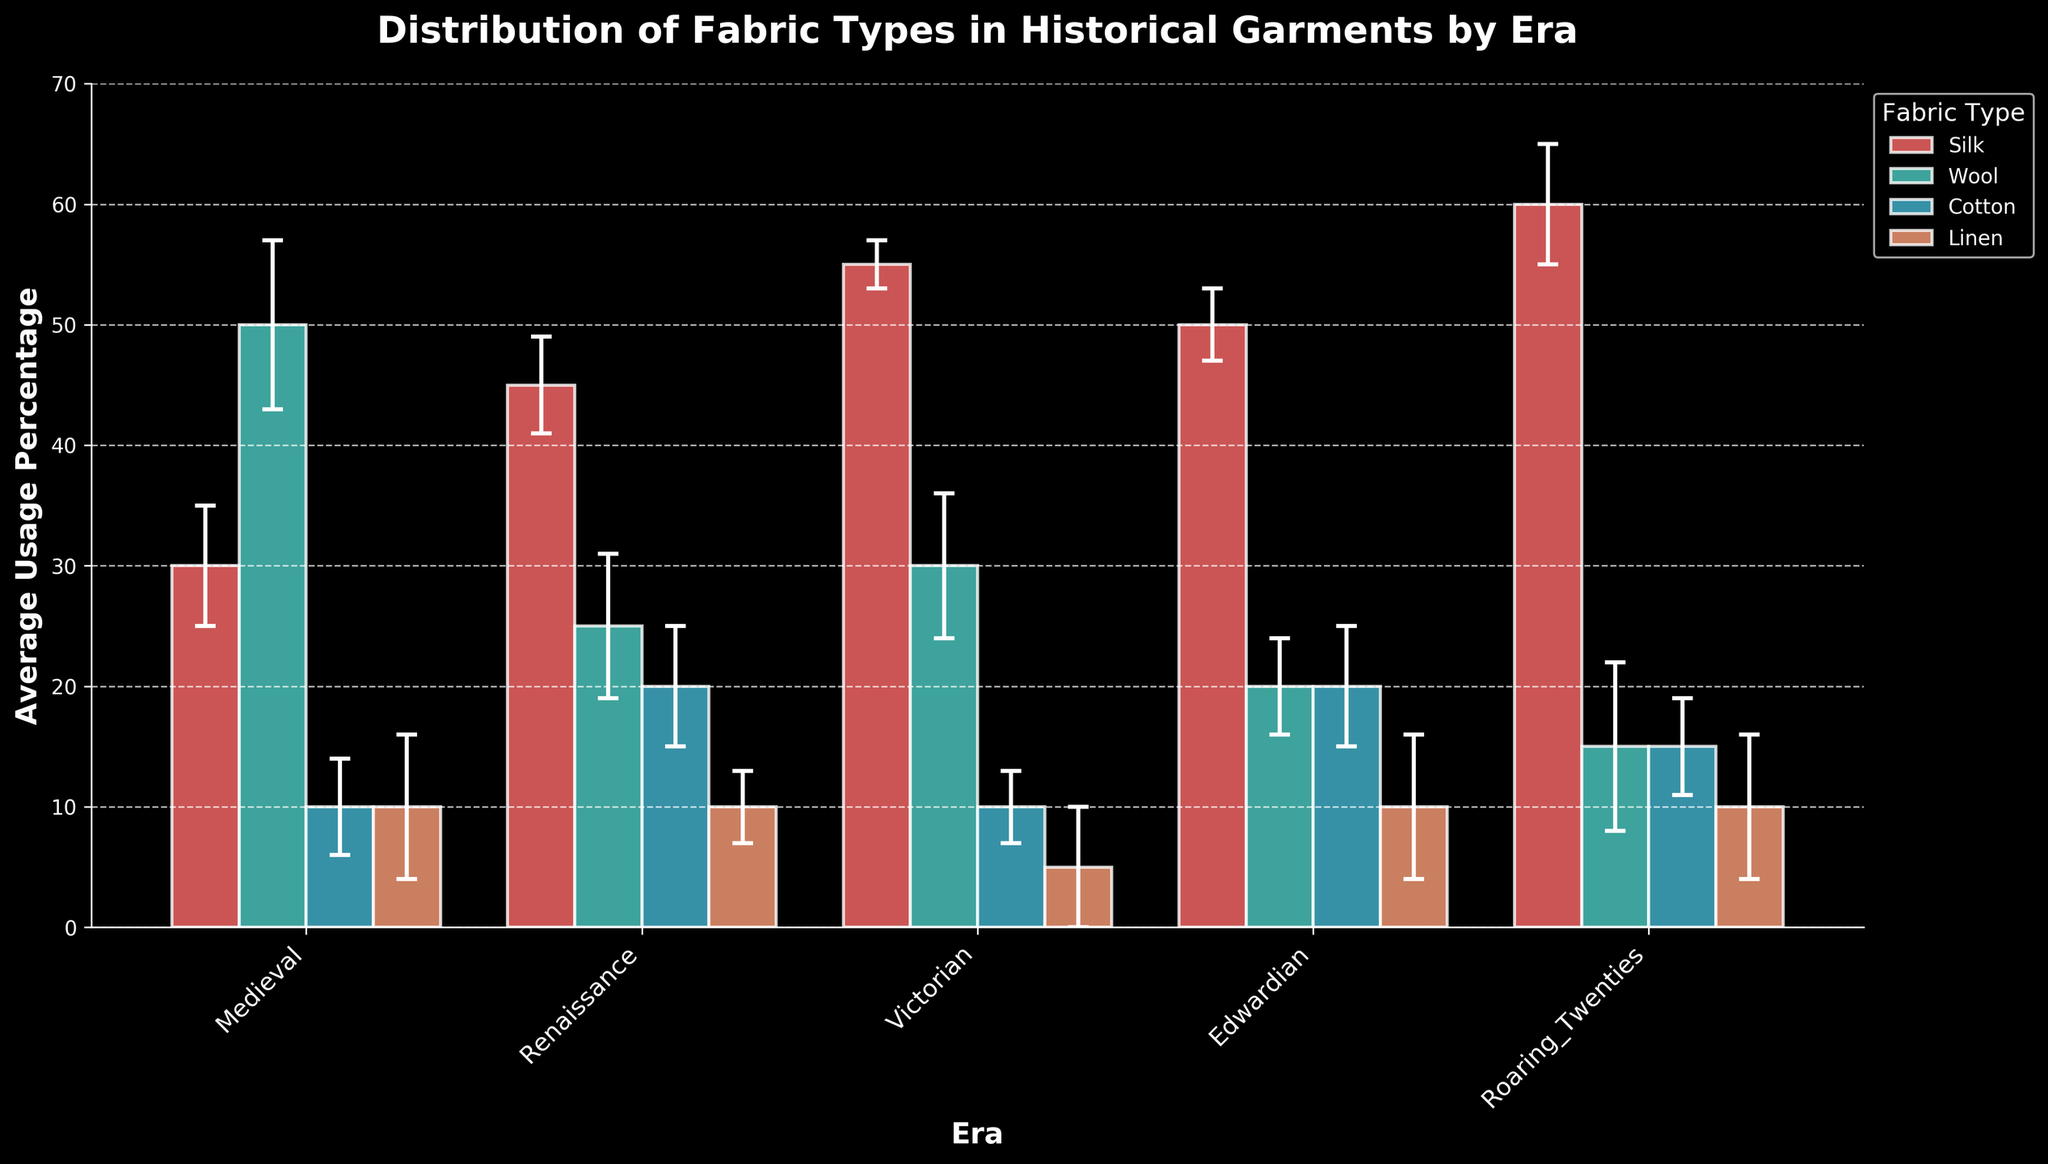What is the title of the chart? The title is usually found at the top of the chart and it provides an overview of the content and purpose of the visualization.
Answer: Distribution of Fabric Types in Historical Garments by Era What era has the highest average usage percentage of silk? Look at the bars corresponding to silk in each era and compare their heights. The highest bar indicates the highest average usage percentage.
Answer: Roaring Twenties Which fabric type has the lowest usage percentage in the Victorian era? Identify the bars under the Victorian era and check their heights for each fabric type. The shortest bar represents the lowest usage percentage.
Answer: Linen Are the error bars for cotton in the Medieval and Renaissance eras overlapping? Compare the error bars for cotton in both eras. Error bars overlap if the range of values they represent intersects.
Answer: No What is the average usage percentage of wool in the Medieval and Edwardian eras? Find the usage percentages for wool in both eras and calculate their average: (50% for Medieval and 20% for Edwardian).
Answer: 35% Which fabric has the highest variability in preservation quality during the Roaring Twenties era, based on error percentage? In the Roaring Twenties section, observe the error bars' length for each fabric. The fabric with the longest error bar shows the highest variability.
Answer: Wool In which era is the difference between the usage percentages of silk and cotton the greatest? Calculate the difference between silk and cotton usage percentages in each era and compare them. The greatest difference indicates the correct era.
Answer: Roaring Twenties Which era demonstrates the most uniform usage across all four fabric types? Check the bars' heights in each era to see which one shows the most balanced distribution (smallest variance) in usage percentages among all fabric types.
Answer: Edwardian Which fabric type consistently shows moderate preservation quality across multiple eras? Look for the preservation quality labels associated with each fabric type across different eras and identify the one with 'Moderate' quality in multiple eras.
Answer: Wool 